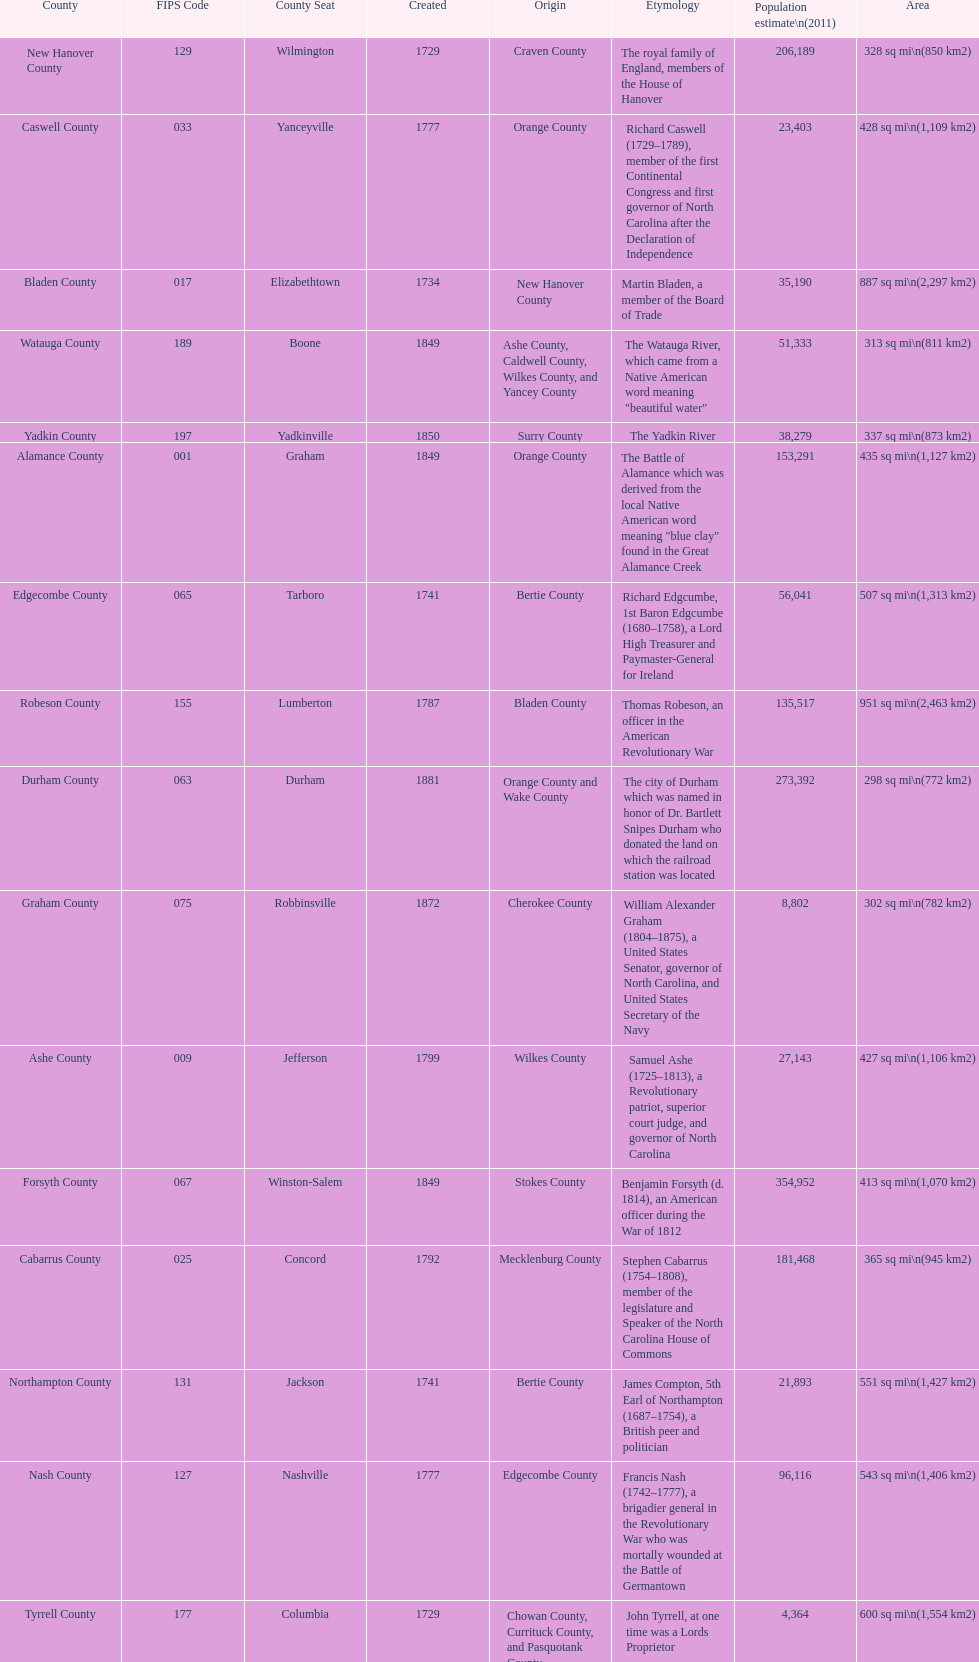What is the number of counties created in the 1800s? 37. 